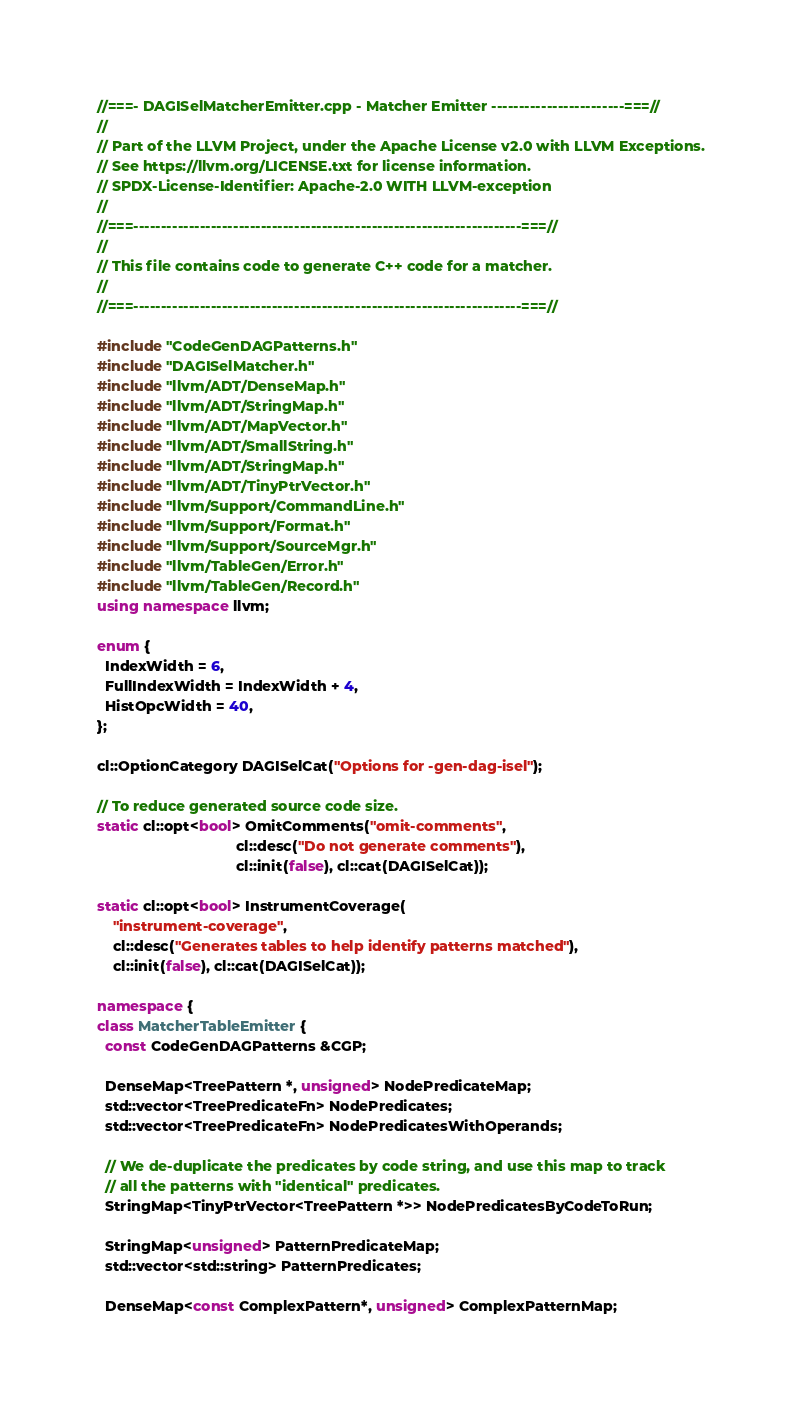<code> <loc_0><loc_0><loc_500><loc_500><_C++_>//===- DAGISelMatcherEmitter.cpp - Matcher Emitter ------------------------===//
//
// Part of the LLVM Project, under the Apache License v2.0 with LLVM Exceptions.
// See https://llvm.org/LICENSE.txt for license information.
// SPDX-License-Identifier: Apache-2.0 WITH LLVM-exception
//
//===----------------------------------------------------------------------===//
//
// This file contains code to generate C++ code for a matcher.
//
//===----------------------------------------------------------------------===//

#include "CodeGenDAGPatterns.h"
#include "DAGISelMatcher.h"
#include "llvm/ADT/DenseMap.h"
#include "llvm/ADT/StringMap.h"
#include "llvm/ADT/MapVector.h"
#include "llvm/ADT/SmallString.h"
#include "llvm/ADT/StringMap.h"
#include "llvm/ADT/TinyPtrVector.h"
#include "llvm/Support/CommandLine.h"
#include "llvm/Support/Format.h"
#include "llvm/Support/SourceMgr.h"
#include "llvm/TableGen/Error.h"
#include "llvm/TableGen/Record.h"
using namespace llvm;

enum {
  IndexWidth = 6,
  FullIndexWidth = IndexWidth + 4,
  HistOpcWidth = 40,
};

cl::OptionCategory DAGISelCat("Options for -gen-dag-isel");

// To reduce generated source code size.
static cl::opt<bool> OmitComments("omit-comments",
                                  cl::desc("Do not generate comments"),
                                  cl::init(false), cl::cat(DAGISelCat));

static cl::opt<bool> InstrumentCoverage(
    "instrument-coverage",
    cl::desc("Generates tables to help identify patterns matched"),
    cl::init(false), cl::cat(DAGISelCat));

namespace {
class MatcherTableEmitter {
  const CodeGenDAGPatterns &CGP;

  DenseMap<TreePattern *, unsigned> NodePredicateMap;
  std::vector<TreePredicateFn> NodePredicates;
  std::vector<TreePredicateFn> NodePredicatesWithOperands;

  // We de-duplicate the predicates by code string, and use this map to track
  // all the patterns with "identical" predicates.
  StringMap<TinyPtrVector<TreePattern *>> NodePredicatesByCodeToRun;

  StringMap<unsigned> PatternPredicateMap;
  std::vector<std::string> PatternPredicates;

  DenseMap<const ComplexPattern*, unsigned> ComplexPatternMap;</code> 